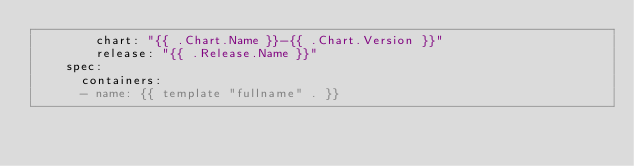<code> <loc_0><loc_0><loc_500><loc_500><_YAML_>        chart: "{{ .Chart.Name }}-{{ .Chart.Version }}"
        release: "{{ .Release.Name }}"
    spec:
      containers:
      - name: {{ template "fullname" . }}</code> 